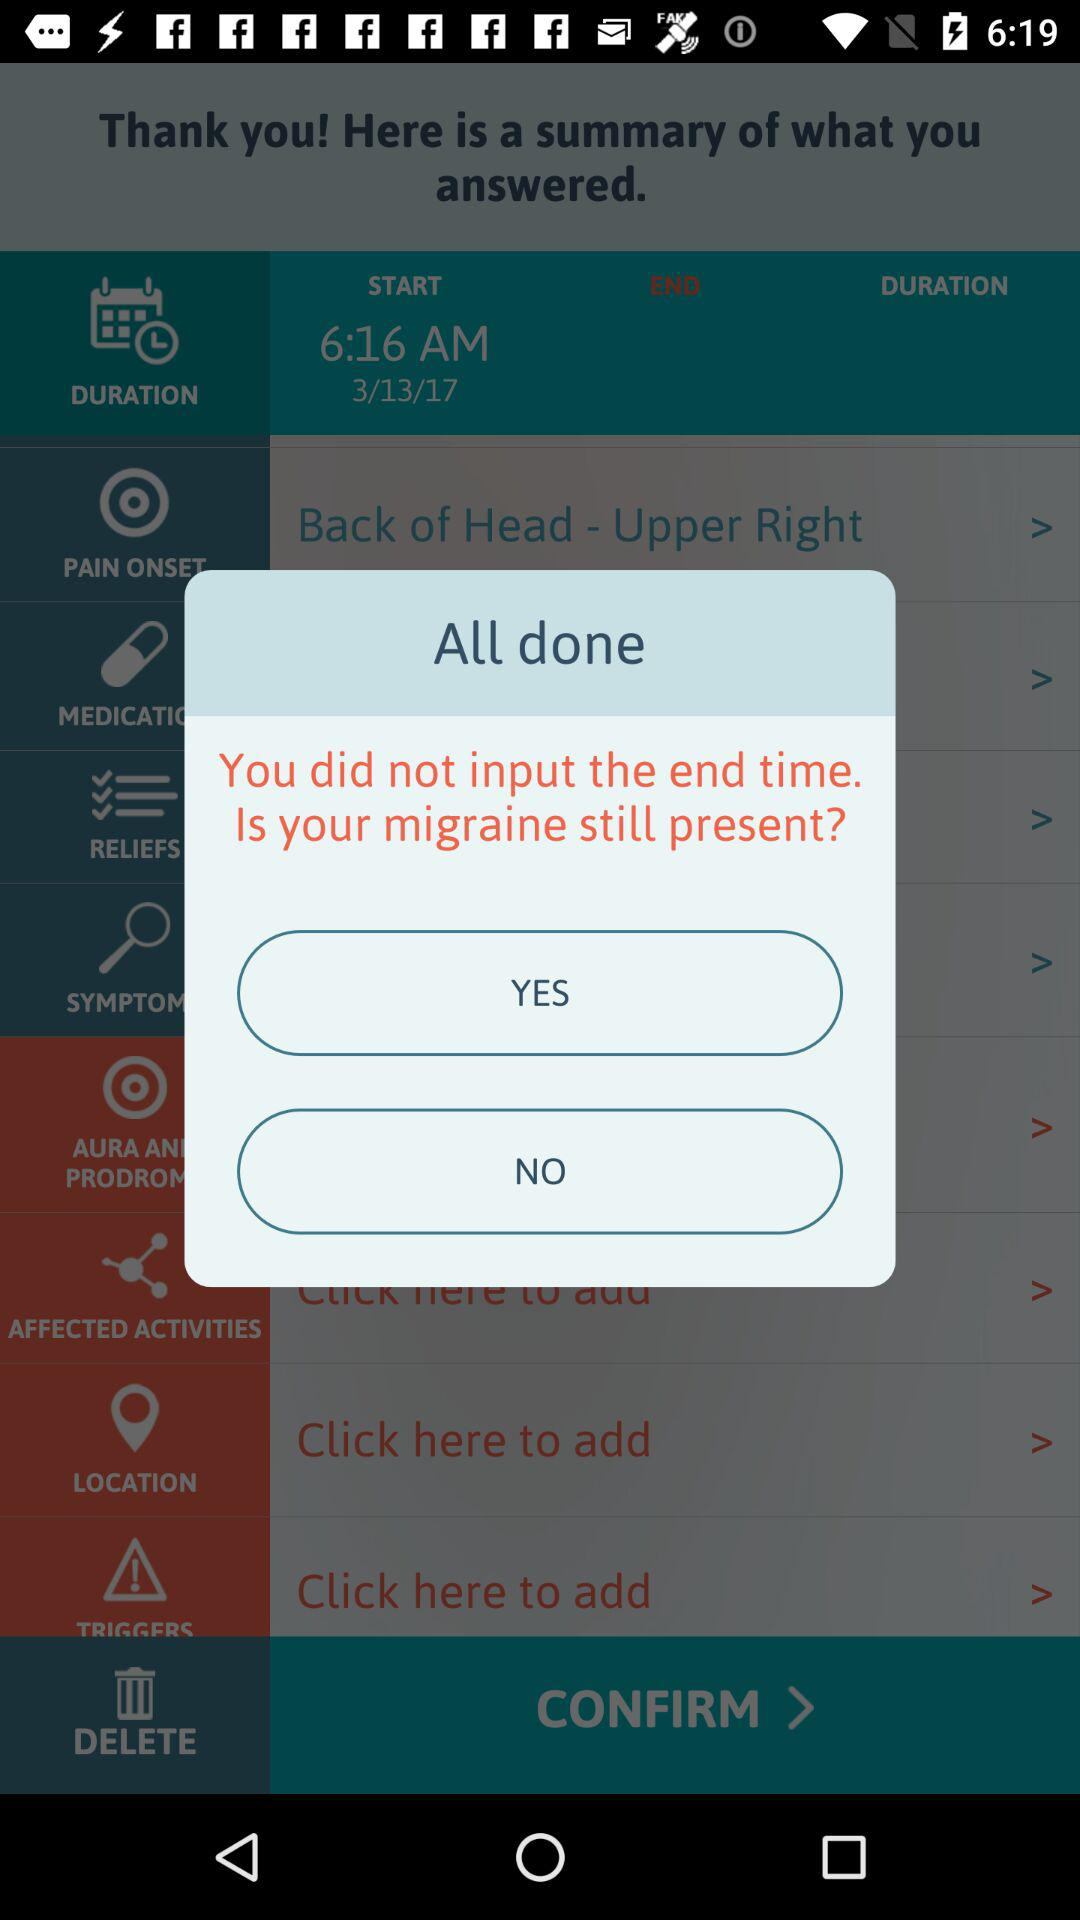What is the mentioned date? The mentioned date is March 13, 2017. 